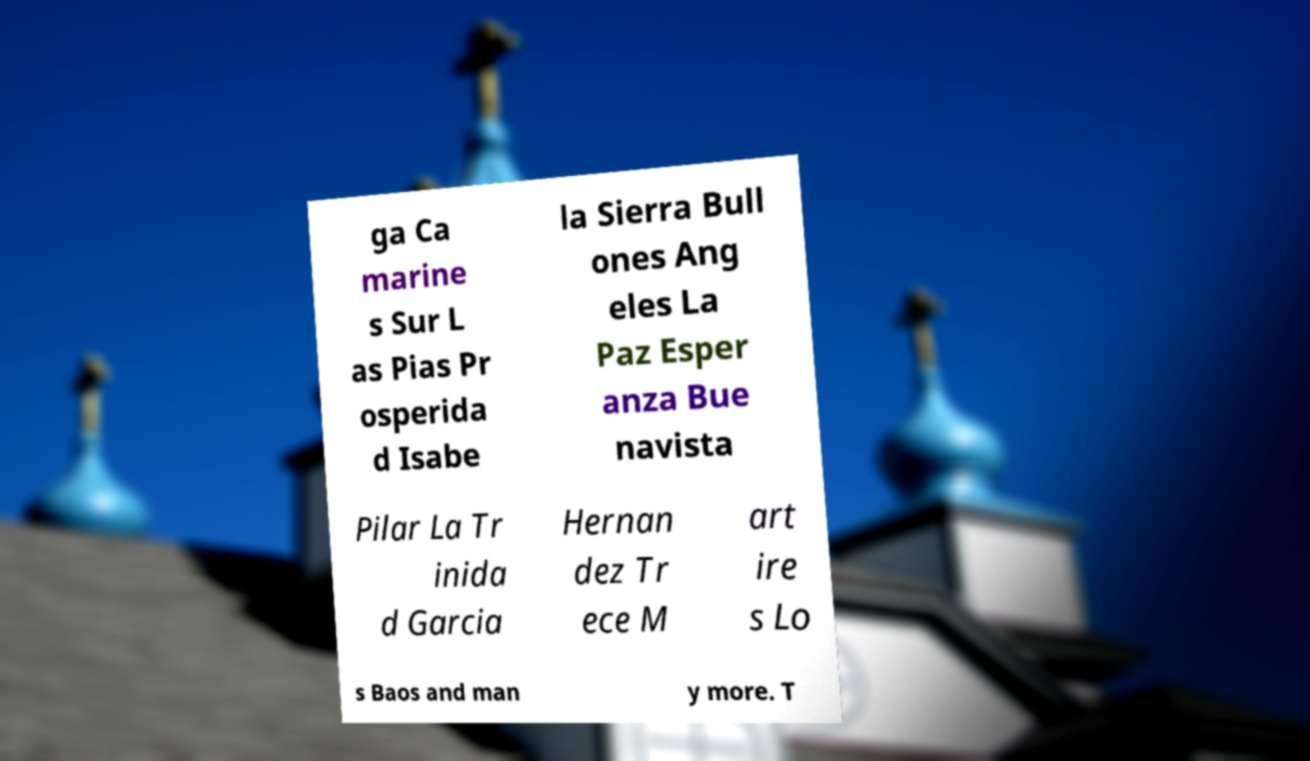Can you read and provide the text displayed in the image?This photo seems to have some interesting text. Can you extract and type it out for me? ga Ca marine s Sur L as Pias Pr osperida d Isabe la Sierra Bull ones Ang eles La Paz Esper anza Bue navista Pilar La Tr inida d Garcia Hernan dez Tr ece M art ire s Lo s Baos and man y more. T 